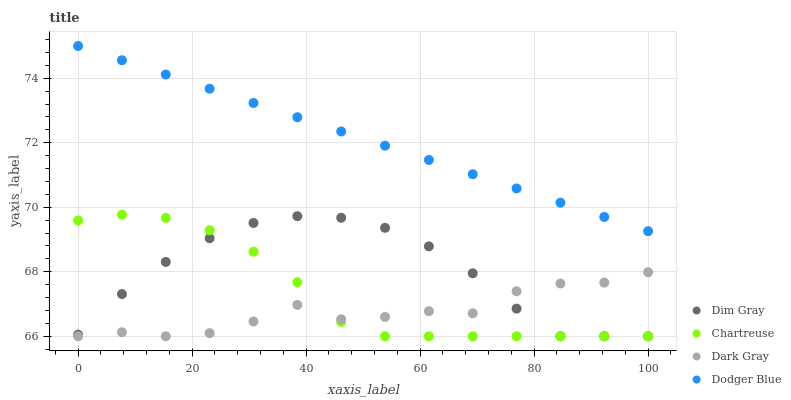Does Dark Gray have the minimum area under the curve?
Answer yes or no. Yes. Does Dodger Blue have the maximum area under the curve?
Answer yes or no. Yes. Does Chartreuse have the minimum area under the curve?
Answer yes or no. No. Does Chartreuse have the maximum area under the curve?
Answer yes or no. No. Is Dodger Blue the smoothest?
Answer yes or no. Yes. Is Dark Gray the roughest?
Answer yes or no. Yes. Is Chartreuse the smoothest?
Answer yes or no. No. Is Chartreuse the roughest?
Answer yes or no. No. Does Dark Gray have the lowest value?
Answer yes or no. Yes. Does Dodger Blue have the lowest value?
Answer yes or no. No. Does Dodger Blue have the highest value?
Answer yes or no. Yes. Does Chartreuse have the highest value?
Answer yes or no. No. Is Dim Gray less than Dodger Blue?
Answer yes or no. Yes. Is Dodger Blue greater than Dark Gray?
Answer yes or no. Yes. Does Chartreuse intersect Dark Gray?
Answer yes or no. Yes. Is Chartreuse less than Dark Gray?
Answer yes or no. No. Is Chartreuse greater than Dark Gray?
Answer yes or no. No. Does Dim Gray intersect Dodger Blue?
Answer yes or no. No. 